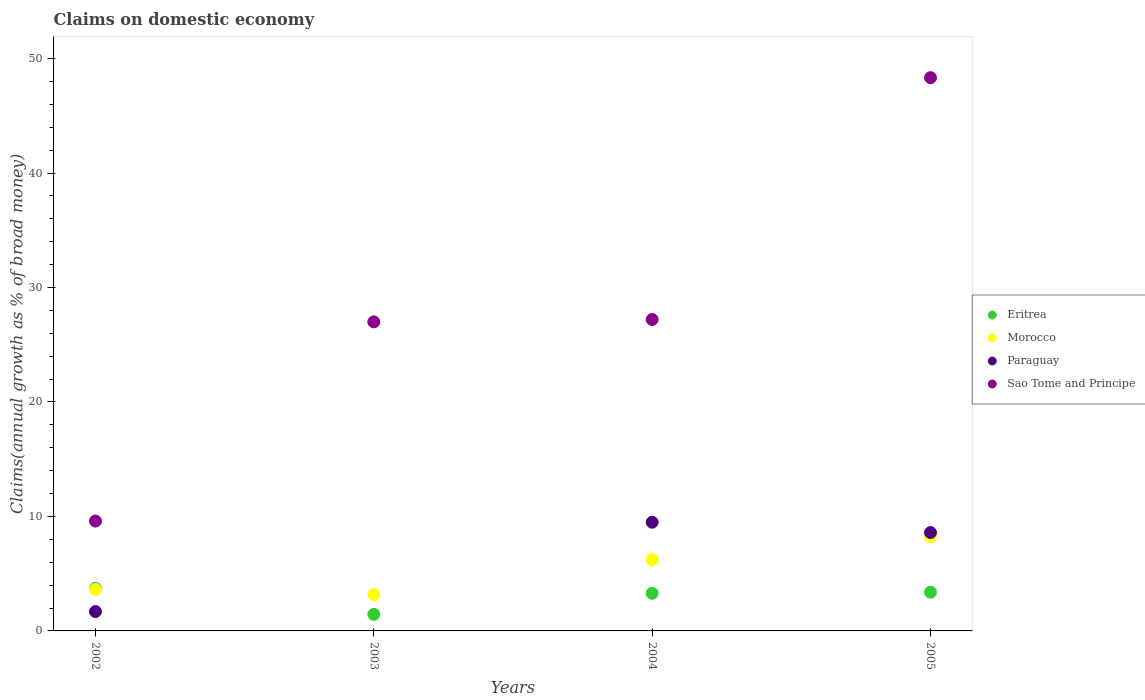How many different coloured dotlines are there?
Ensure brevity in your answer.  4. Is the number of dotlines equal to the number of legend labels?
Offer a very short reply. No. What is the percentage of broad money claimed on domestic economy in Eritrea in 2005?
Your answer should be compact. 3.39. Across all years, what is the maximum percentage of broad money claimed on domestic economy in Paraguay?
Make the answer very short. 9.5. What is the total percentage of broad money claimed on domestic economy in Paraguay in the graph?
Your answer should be compact. 19.78. What is the difference between the percentage of broad money claimed on domestic economy in Morocco in 2003 and that in 2004?
Make the answer very short. -3.07. What is the difference between the percentage of broad money claimed on domestic economy in Morocco in 2004 and the percentage of broad money claimed on domestic economy in Eritrea in 2002?
Keep it short and to the point. 2.51. What is the average percentage of broad money claimed on domestic economy in Sao Tome and Principe per year?
Ensure brevity in your answer.  28.04. In the year 2002, what is the difference between the percentage of broad money claimed on domestic economy in Sao Tome and Principe and percentage of broad money claimed on domestic economy in Paraguay?
Offer a very short reply. 7.91. What is the ratio of the percentage of broad money claimed on domestic economy in Sao Tome and Principe in 2002 to that in 2003?
Your answer should be compact. 0.36. What is the difference between the highest and the second highest percentage of broad money claimed on domestic economy in Eritrea?
Offer a very short reply. 0.33. What is the difference between the highest and the lowest percentage of broad money claimed on domestic economy in Morocco?
Make the answer very short. 5.08. Is it the case that in every year, the sum of the percentage of broad money claimed on domestic economy in Eritrea and percentage of broad money claimed on domestic economy in Morocco  is greater than the sum of percentage of broad money claimed on domestic economy in Paraguay and percentage of broad money claimed on domestic economy in Sao Tome and Principe?
Your answer should be compact. No. Is it the case that in every year, the sum of the percentage of broad money claimed on domestic economy in Paraguay and percentage of broad money claimed on domestic economy in Eritrea  is greater than the percentage of broad money claimed on domestic economy in Morocco?
Your response must be concise. No. Does the percentage of broad money claimed on domestic economy in Eritrea monotonically increase over the years?
Provide a succinct answer. No. Is the percentage of broad money claimed on domestic economy in Paraguay strictly greater than the percentage of broad money claimed on domestic economy in Eritrea over the years?
Your response must be concise. No. How many dotlines are there?
Ensure brevity in your answer.  4. How many legend labels are there?
Make the answer very short. 4. What is the title of the graph?
Give a very brief answer. Claims on domestic economy. What is the label or title of the X-axis?
Keep it short and to the point. Years. What is the label or title of the Y-axis?
Your answer should be very brief. Claims(annual growth as % of broad money). What is the Claims(annual growth as % of broad money) in Eritrea in 2002?
Provide a short and direct response. 3.72. What is the Claims(annual growth as % of broad money) of Morocco in 2002?
Provide a short and direct response. 3.62. What is the Claims(annual growth as % of broad money) in Paraguay in 2002?
Your response must be concise. 1.69. What is the Claims(annual growth as % of broad money) of Sao Tome and Principe in 2002?
Offer a very short reply. 9.6. What is the Claims(annual growth as % of broad money) in Eritrea in 2003?
Offer a very short reply. 1.45. What is the Claims(annual growth as % of broad money) of Morocco in 2003?
Provide a short and direct response. 3.16. What is the Claims(annual growth as % of broad money) in Paraguay in 2003?
Your response must be concise. 0. What is the Claims(annual growth as % of broad money) in Sao Tome and Principe in 2003?
Offer a terse response. 27. What is the Claims(annual growth as % of broad money) in Eritrea in 2004?
Keep it short and to the point. 3.29. What is the Claims(annual growth as % of broad money) of Morocco in 2004?
Make the answer very short. 6.23. What is the Claims(annual growth as % of broad money) of Paraguay in 2004?
Your response must be concise. 9.5. What is the Claims(annual growth as % of broad money) in Sao Tome and Principe in 2004?
Your answer should be very brief. 27.21. What is the Claims(annual growth as % of broad money) of Eritrea in 2005?
Ensure brevity in your answer.  3.39. What is the Claims(annual growth as % of broad money) in Morocco in 2005?
Offer a very short reply. 8.24. What is the Claims(annual growth as % of broad money) in Paraguay in 2005?
Your answer should be very brief. 8.59. What is the Claims(annual growth as % of broad money) of Sao Tome and Principe in 2005?
Offer a terse response. 48.33. Across all years, what is the maximum Claims(annual growth as % of broad money) of Eritrea?
Your answer should be compact. 3.72. Across all years, what is the maximum Claims(annual growth as % of broad money) of Morocco?
Ensure brevity in your answer.  8.24. Across all years, what is the maximum Claims(annual growth as % of broad money) of Paraguay?
Make the answer very short. 9.5. Across all years, what is the maximum Claims(annual growth as % of broad money) of Sao Tome and Principe?
Your response must be concise. 48.33. Across all years, what is the minimum Claims(annual growth as % of broad money) in Eritrea?
Keep it short and to the point. 1.45. Across all years, what is the minimum Claims(annual growth as % of broad money) of Morocco?
Provide a succinct answer. 3.16. Across all years, what is the minimum Claims(annual growth as % of broad money) in Paraguay?
Ensure brevity in your answer.  0. Across all years, what is the minimum Claims(annual growth as % of broad money) of Sao Tome and Principe?
Provide a short and direct response. 9.6. What is the total Claims(annual growth as % of broad money) of Eritrea in the graph?
Offer a terse response. 11.84. What is the total Claims(annual growth as % of broad money) in Morocco in the graph?
Your answer should be very brief. 21.25. What is the total Claims(annual growth as % of broad money) in Paraguay in the graph?
Ensure brevity in your answer.  19.78. What is the total Claims(annual growth as % of broad money) in Sao Tome and Principe in the graph?
Your response must be concise. 112.14. What is the difference between the Claims(annual growth as % of broad money) in Eritrea in 2002 and that in 2003?
Provide a succinct answer. 2.27. What is the difference between the Claims(annual growth as % of broad money) of Morocco in 2002 and that in 2003?
Give a very brief answer. 0.46. What is the difference between the Claims(annual growth as % of broad money) in Sao Tome and Principe in 2002 and that in 2003?
Your answer should be compact. -17.4. What is the difference between the Claims(annual growth as % of broad money) in Eritrea in 2002 and that in 2004?
Your response must be concise. 0.43. What is the difference between the Claims(annual growth as % of broad money) in Morocco in 2002 and that in 2004?
Your answer should be very brief. -2.61. What is the difference between the Claims(annual growth as % of broad money) in Paraguay in 2002 and that in 2004?
Offer a terse response. -7.81. What is the difference between the Claims(annual growth as % of broad money) in Sao Tome and Principe in 2002 and that in 2004?
Offer a terse response. -17.61. What is the difference between the Claims(annual growth as % of broad money) of Eritrea in 2002 and that in 2005?
Give a very brief answer. 0.33. What is the difference between the Claims(annual growth as % of broad money) of Morocco in 2002 and that in 2005?
Your answer should be compact. -4.62. What is the difference between the Claims(annual growth as % of broad money) in Paraguay in 2002 and that in 2005?
Ensure brevity in your answer.  -6.9. What is the difference between the Claims(annual growth as % of broad money) of Sao Tome and Principe in 2002 and that in 2005?
Your response must be concise. -38.73. What is the difference between the Claims(annual growth as % of broad money) in Eritrea in 2003 and that in 2004?
Keep it short and to the point. -1.84. What is the difference between the Claims(annual growth as % of broad money) in Morocco in 2003 and that in 2004?
Your answer should be compact. -3.07. What is the difference between the Claims(annual growth as % of broad money) in Sao Tome and Principe in 2003 and that in 2004?
Provide a succinct answer. -0.21. What is the difference between the Claims(annual growth as % of broad money) of Eritrea in 2003 and that in 2005?
Offer a terse response. -1.94. What is the difference between the Claims(annual growth as % of broad money) of Morocco in 2003 and that in 2005?
Provide a short and direct response. -5.08. What is the difference between the Claims(annual growth as % of broad money) in Sao Tome and Principe in 2003 and that in 2005?
Make the answer very short. -21.33. What is the difference between the Claims(annual growth as % of broad money) in Eritrea in 2004 and that in 2005?
Offer a terse response. -0.1. What is the difference between the Claims(annual growth as % of broad money) in Morocco in 2004 and that in 2005?
Your answer should be very brief. -2.01. What is the difference between the Claims(annual growth as % of broad money) of Paraguay in 2004 and that in 2005?
Offer a very short reply. 0.91. What is the difference between the Claims(annual growth as % of broad money) of Sao Tome and Principe in 2004 and that in 2005?
Offer a terse response. -21.12. What is the difference between the Claims(annual growth as % of broad money) of Eritrea in 2002 and the Claims(annual growth as % of broad money) of Morocco in 2003?
Offer a terse response. 0.56. What is the difference between the Claims(annual growth as % of broad money) in Eritrea in 2002 and the Claims(annual growth as % of broad money) in Sao Tome and Principe in 2003?
Make the answer very short. -23.28. What is the difference between the Claims(annual growth as % of broad money) of Morocco in 2002 and the Claims(annual growth as % of broad money) of Sao Tome and Principe in 2003?
Your response must be concise. -23.38. What is the difference between the Claims(annual growth as % of broad money) in Paraguay in 2002 and the Claims(annual growth as % of broad money) in Sao Tome and Principe in 2003?
Your answer should be compact. -25.31. What is the difference between the Claims(annual growth as % of broad money) in Eritrea in 2002 and the Claims(annual growth as % of broad money) in Morocco in 2004?
Ensure brevity in your answer.  -2.51. What is the difference between the Claims(annual growth as % of broad money) of Eritrea in 2002 and the Claims(annual growth as % of broad money) of Paraguay in 2004?
Make the answer very short. -5.78. What is the difference between the Claims(annual growth as % of broad money) of Eritrea in 2002 and the Claims(annual growth as % of broad money) of Sao Tome and Principe in 2004?
Your answer should be compact. -23.49. What is the difference between the Claims(annual growth as % of broad money) in Morocco in 2002 and the Claims(annual growth as % of broad money) in Paraguay in 2004?
Offer a very short reply. -5.88. What is the difference between the Claims(annual growth as % of broad money) of Morocco in 2002 and the Claims(annual growth as % of broad money) of Sao Tome and Principe in 2004?
Your answer should be compact. -23.59. What is the difference between the Claims(annual growth as % of broad money) of Paraguay in 2002 and the Claims(annual growth as % of broad money) of Sao Tome and Principe in 2004?
Ensure brevity in your answer.  -25.52. What is the difference between the Claims(annual growth as % of broad money) of Eritrea in 2002 and the Claims(annual growth as % of broad money) of Morocco in 2005?
Provide a short and direct response. -4.52. What is the difference between the Claims(annual growth as % of broad money) in Eritrea in 2002 and the Claims(annual growth as % of broad money) in Paraguay in 2005?
Your answer should be very brief. -4.87. What is the difference between the Claims(annual growth as % of broad money) of Eritrea in 2002 and the Claims(annual growth as % of broad money) of Sao Tome and Principe in 2005?
Your answer should be compact. -44.61. What is the difference between the Claims(annual growth as % of broad money) in Morocco in 2002 and the Claims(annual growth as % of broad money) in Paraguay in 2005?
Provide a succinct answer. -4.97. What is the difference between the Claims(annual growth as % of broad money) of Morocco in 2002 and the Claims(annual growth as % of broad money) of Sao Tome and Principe in 2005?
Keep it short and to the point. -44.71. What is the difference between the Claims(annual growth as % of broad money) of Paraguay in 2002 and the Claims(annual growth as % of broad money) of Sao Tome and Principe in 2005?
Make the answer very short. -46.64. What is the difference between the Claims(annual growth as % of broad money) of Eritrea in 2003 and the Claims(annual growth as % of broad money) of Morocco in 2004?
Give a very brief answer. -4.78. What is the difference between the Claims(annual growth as % of broad money) of Eritrea in 2003 and the Claims(annual growth as % of broad money) of Paraguay in 2004?
Provide a short and direct response. -8.05. What is the difference between the Claims(annual growth as % of broad money) of Eritrea in 2003 and the Claims(annual growth as % of broad money) of Sao Tome and Principe in 2004?
Offer a very short reply. -25.76. What is the difference between the Claims(annual growth as % of broad money) in Morocco in 2003 and the Claims(annual growth as % of broad money) in Paraguay in 2004?
Your answer should be very brief. -6.34. What is the difference between the Claims(annual growth as % of broad money) of Morocco in 2003 and the Claims(annual growth as % of broad money) of Sao Tome and Principe in 2004?
Make the answer very short. -24.05. What is the difference between the Claims(annual growth as % of broad money) in Eritrea in 2003 and the Claims(annual growth as % of broad money) in Morocco in 2005?
Your response must be concise. -6.79. What is the difference between the Claims(annual growth as % of broad money) in Eritrea in 2003 and the Claims(annual growth as % of broad money) in Paraguay in 2005?
Make the answer very short. -7.14. What is the difference between the Claims(annual growth as % of broad money) of Eritrea in 2003 and the Claims(annual growth as % of broad money) of Sao Tome and Principe in 2005?
Your answer should be very brief. -46.89. What is the difference between the Claims(annual growth as % of broad money) in Morocco in 2003 and the Claims(annual growth as % of broad money) in Paraguay in 2005?
Give a very brief answer. -5.43. What is the difference between the Claims(annual growth as % of broad money) of Morocco in 2003 and the Claims(annual growth as % of broad money) of Sao Tome and Principe in 2005?
Provide a short and direct response. -45.17. What is the difference between the Claims(annual growth as % of broad money) in Eritrea in 2004 and the Claims(annual growth as % of broad money) in Morocco in 2005?
Ensure brevity in your answer.  -4.95. What is the difference between the Claims(annual growth as % of broad money) of Eritrea in 2004 and the Claims(annual growth as % of broad money) of Paraguay in 2005?
Keep it short and to the point. -5.3. What is the difference between the Claims(annual growth as % of broad money) of Eritrea in 2004 and the Claims(annual growth as % of broad money) of Sao Tome and Principe in 2005?
Make the answer very short. -45.05. What is the difference between the Claims(annual growth as % of broad money) of Morocco in 2004 and the Claims(annual growth as % of broad money) of Paraguay in 2005?
Provide a succinct answer. -2.37. What is the difference between the Claims(annual growth as % of broad money) in Morocco in 2004 and the Claims(annual growth as % of broad money) in Sao Tome and Principe in 2005?
Offer a very short reply. -42.11. What is the difference between the Claims(annual growth as % of broad money) of Paraguay in 2004 and the Claims(annual growth as % of broad money) of Sao Tome and Principe in 2005?
Ensure brevity in your answer.  -38.84. What is the average Claims(annual growth as % of broad money) in Eritrea per year?
Give a very brief answer. 2.96. What is the average Claims(annual growth as % of broad money) of Morocco per year?
Your answer should be compact. 5.31. What is the average Claims(annual growth as % of broad money) of Paraguay per year?
Your answer should be compact. 4.95. What is the average Claims(annual growth as % of broad money) of Sao Tome and Principe per year?
Offer a very short reply. 28.04. In the year 2002, what is the difference between the Claims(annual growth as % of broad money) of Eritrea and Claims(annual growth as % of broad money) of Morocco?
Offer a terse response. 0.1. In the year 2002, what is the difference between the Claims(annual growth as % of broad money) of Eritrea and Claims(annual growth as % of broad money) of Paraguay?
Keep it short and to the point. 2.03. In the year 2002, what is the difference between the Claims(annual growth as % of broad money) in Eritrea and Claims(annual growth as % of broad money) in Sao Tome and Principe?
Your answer should be very brief. -5.88. In the year 2002, what is the difference between the Claims(annual growth as % of broad money) in Morocco and Claims(annual growth as % of broad money) in Paraguay?
Keep it short and to the point. 1.93. In the year 2002, what is the difference between the Claims(annual growth as % of broad money) of Morocco and Claims(annual growth as % of broad money) of Sao Tome and Principe?
Keep it short and to the point. -5.98. In the year 2002, what is the difference between the Claims(annual growth as % of broad money) of Paraguay and Claims(annual growth as % of broad money) of Sao Tome and Principe?
Offer a terse response. -7.91. In the year 2003, what is the difference between the Claims(annual growth as % of broad money) in Eritrea and Claims(annual growth as % of broad money) in Morocco?
Ensure brevity in your answer.  -1.71. In the year 2003, what is the difference between the Claims(annual growth as % of broad money) of Eritrea and Claims(annual growth as % of broad money) of Sao Tome and Principe?
Offer a terse response. -25.55. In the year 2003, what is the difference between the Claims(annual growth as % of broad money) of Morocco and Claims(annual growth as % of broad money) of Sao Tome and Principe?
Your answer should be very brief. -23.84. In the year 2004, what is the difference between the Claims(annual growth as % of broad money) of Eritrea and Claims(annual growth as % of broad money) of Morocco?
Offer a terse response. -2.94. In the year 2004, what is the difference between the Claims(annual growth as % of broad money) in Eritrea and Claims(annual growth as % of broad money) in Paraguay?
Make the answer very short. -6.21. In the year 2004, what is the difference between the Claims(annual growth as % of broad money) in Eritrea and Claims(annual growth as % of broad money) in Sao Tome and Principe?
Offer a very short reply. -23.92. In the year 2004, what is the difference between the Claims(annual growth as % of broad money) in Morocco and Claims(annual growth as % of broad money) in Paraguay?
Give a very brief answer. -3.27. In the year 2004, what is the difference between the Claims(annual growth as % of broad money) of Morocco and Claims(annual growth as % of broad money) of Sao Tome and Principe?
Keep it short and to the point. -20.98. In the year 2004, what is the difference between the Claims(annual growth as % of broad money) of Paraguay and Claims(annual growth as % of broad money) of Sao Tome and Principe?
Make the answer very short. -17.71. In the year 2005, what is the difference between the Claims(annual growth as % of broad money) in Eritrea and Claims(annual growth as % of broad money) in Morocco?
Offer a very short reply. -4.85. In the year 2005, what is the difference between the Claims(annual growth as % of broad money) in Eritrea and Claims(annual growth as % of broad money) in Paraguay?
Offer a terse response. -5.21. In the year 2005, what is the difference between the Claims(annual growth as % of broad money) of Eritrea and Claims(annual growth as % of broad money) of Sao Tome and Principe?
Offer a terse response. -44.95. In the year 2005, what is the difference between the Claims(annual growth as % of broad money) in Morocco and Claims(annual growth as % of broad money) in Paraguay?
Offer a very short reply. -0.35. In the year 2005, what is the difference between the Claims(annual growth as % of broad money) in Morocco and Claims(annual growth as % of broad money) in Sao Tome and Principe?
Provide a short and direct response. -40.09. In the year 2005, what is the difference between the Claims(annual growth as % of broad money) of Paraguay and Claims(annual growth as % of broad money) of Sao Tome and Principe?
Ensure brevity in your answer.  -39.74. What is the ratio of the Claims(annual growth as % of broad money) of Eritrea in 2002 to that in 2003?
Give a very brief answer. 2.57. What is the ratio of the Claims(annual growth as % of broad money) of Morocco in 2002 to that in 2003?
Your answer should be very brief. 1.14. What is the ratio of the Claims(annual growth as % of broad money) of Sao Tome and Principe in 2002 to that in 2003?
Make the answer very short. 0.36. What is the ratio of the Claims(annual growth as % of broad money) of Eritrea in 2002 to that in 2004?
Your response must be concise. 1.13. What is the ratio of the Claims(annual growth as % of broad money) in Morocco in 2002 to that in 2004?
Your response must be concise. 0.58. What is the ratio of the Claims(annual growth as % of broad money) in Paraguay in 2002 to that in 2004?
Your answer should be very brief. 0.18. What is the ratio of the Claims(annual growth as % of broad money) in Sao Tome and Principe in 2002 to that in 2004?
Ensure brevity in your answer.  0.35. What is the ratio of the Claims(annual growth as % of broad money) of Eritrea in 2002 to that in 2005?
Ensure brevity in your answer.  1.1. What is the ratio of the Claims(annual growth as % of broad money) in Morocco in 2002 to that in 2005?
Give a very brief answer. 0.44. What is the ratio of the Claims(annual growth as % of broad money) of Paraguay in 2002 to that in 2005?
Make the answer very short. 0.2. What is the ratio of the Claims(annual growth as % of broad money) in Sao Tome and Principe in 2002 to that in 2005?
Ensure brevity in your answer.  0.2. What is the ratio of the Claims(annual growth as % of broad money) of Eritrea in 2003 to that in 2004?
Ensure brevity in your answer.  0.44. What is the ratio of the Claims(annual growth as % of broad money) in Morocco in 2003 to that in 2004?
Ensure brevity in your answer.  0.51. What is the ratio of the Claims(annual growth as % of broad money) of Eritrea in 2003 to that in 2005?
Your response must be concise. 0.43. What is the ratio of the Claims(annual growth as % of broad money) in Morocco in 2003 to that in 2005?
Offer a terse response. 0.38. What is the ratio of the Claims(annual growth as % of broad money) of Sao Tome and Principe in 2003 to that in 2005?
Your response must be concise. 0.56. What is the ratio of the Claims(annual growth as % of broad money) of Eritrea in 2004 to that in 2005?
Your response must be concise. 0.97. What is the ratio of the Claims(annual growth as % of broad money) in Morocco in 2004 to that in 2005?
Give a very brief answer. 0.76. What is the ratio of the Claims(annual growth as % of broad money) in Paraguay in 2004 to that in 2005?
Offer a very short reply. 1.11. What is the ratio of the Claims(annual growth as % of broad money) in Sao Tome and Principe in 2004 to that in 2005?
Provide a short and direct response. 0.56. What is the difference between the highest and the second highest Claims(annual growth as % of broad money) of Eritrea?
Keep it short and to the point. 0.33. What is the difference between the highest and the second highest Claims(annual growth as % of broad money) of Morocco?
Keep it short and to the point. 2.01. What is the difference between the highest and the second highest Claims(annual growth as % of broad money) of Paraguay?
Provide a succinct answer. 0.91. What is the difference between the highest and the second highest Claims(annual growth as % of broad money) in Sao Tome and Principe?
Make the answer very short. 21.12. What is the difference between the highest and the lowest Claims(annual growth as % of broad money) in Eritrea?
Your answer should be very brief. 2.27. What is the difference between the highest and the lowest Claims(annual growth as % of broad money) of Morocco?
Make the answer very short. 5.08. What is the difference between the highest and the lowest Claims(annual growth as % of broad money) of Paraguay?
Your answer should be compact. 9.5. What is the difference between the highest and the lowest Claims(annual growth as % of broad money) of Sao Tome and Principe?
Your answer should be very brief. 38.73. 